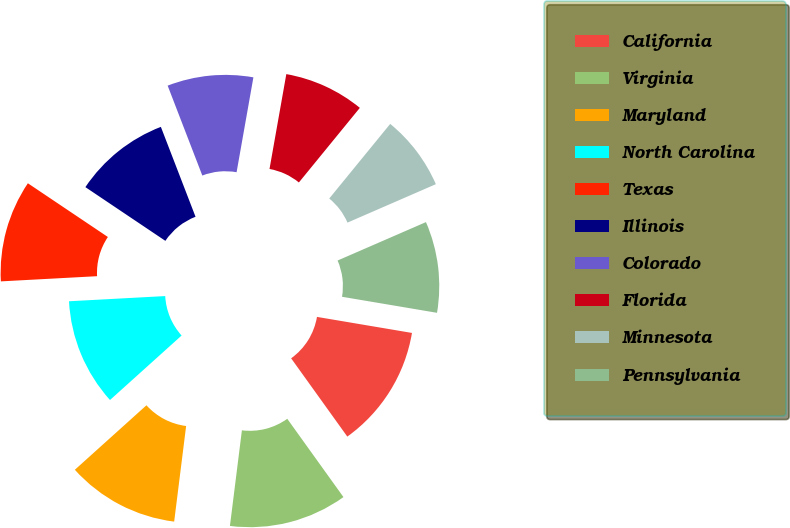Convert chart. <chart><loc_0><loc_0><loc_500><loc_500><pie_chart><fcel>California<fcel>Virginia<fcel>Maryland<fcel>North Carolina<fcel>Texas<fcel>Illinois<fcel>Colorado<fcel>Florida<fcel>Minnesota<fcel>Pennsylvania<nl><fcel>12.43%<fcel>11.89%<fcel>11.35%<fcel>10.81%<fcel>10.27%<fcel>9.73%<fcel>8.65%<fcel>8.11%<fcel>7.57%<fcel>9.19%<nl></chart> 